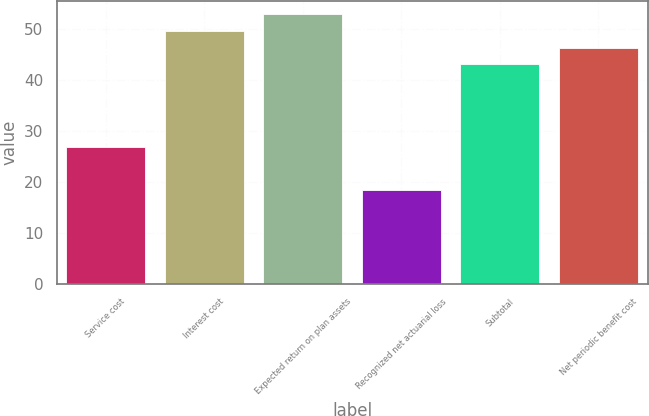Convert chart. <chart><loc_0><loc_0><loc_500><loc_500><bar_chart><fcel>Service cost<fcel>Interest cost<fcel>Expected return on plan assets<fcel>Recognized net actuarial loss<fcel>Subtotal<fcel>Net periodic benefit cost<nl><fcel>26.9<fcel>49.54<fcel>52.81<fcel>18.4<fcel>43<fcel>46.27<nl></chart> 